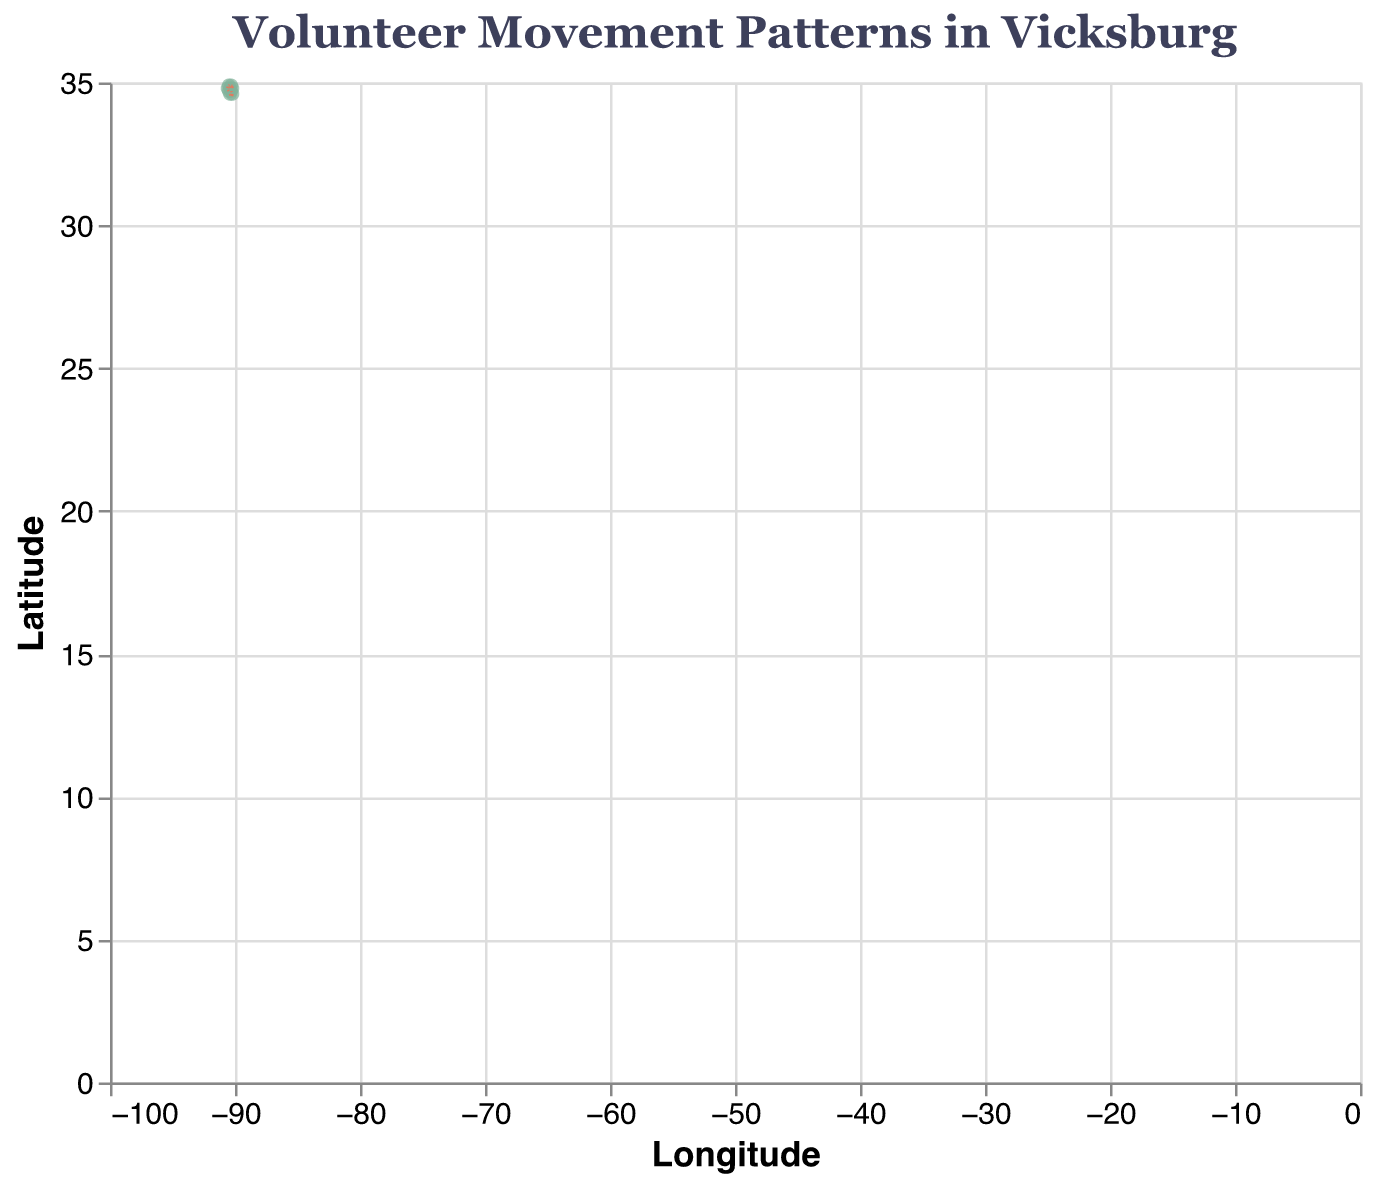What is the title of the plot? The title of the plot is displayed at the top and is usually the most noticeable textual element.
Answer: Volunteer Movement Patterns in Vicksburg How many volunteer locations are displayed in the plot? By counting the distinct data points (or locations) represented in the plot, you can determine the number.
Answer: 9 What color is used to represent the points indicating volunteer locations? The points representing volunteer locations are typically marked with a consistent color for uniformity and to distinguish them easily from other elements.
Answer: #81B29A What is the direction of volunteer movement at the Vicksburg National Military Park? The direction is given by the vector, where `U` represents the horizontal change, and `V` the vertical change. For Vicksburg National Military Park: (0.1, -0.2).
Answer: Right and down Which location exhibits the strongest opposite direction of movement compared to Vicksburg Warren School District? To find the opposite direction, we identify vectors where `U` and `V` components are inverse to those of the Vicksburg Warren School District (-0.2, 0.3).
Answer: Salvation Army of Vicksburg (U=-0.2, V=-0.4) What is the general movement pattern at Vicksburg National Cemetery? Look at the vector associated with the National Cemetery's coordinates. U and V components give the movement pattern: (0.1, 0.3).
Answer: Minor right and significant up Which locations have volunteer movements in the vertical upward direction? Search for vectors with positive V components indicating upward movements in the plot.
Answer: Vicksburg Warren School District, Good Shepherd Community Center, Vicksburg Convention Center, Vicksburg National Cemetery What is the average horizontal movement (U) across all locations? Add up all the `U` values and divide by the number of locations: (-0.2 + 0.1 + 0.3 - 0.1 + 0.2 - 0.3 + 0.4 + 0.1 - 0.2) / 9.
Answer: 0.022 Between the Vicksburg Convention Center and Warren County-Vicksburg Public Library, which had the greater vertical movement? Compare the absolute values of their `V` components (-0.3, 0.2) to see which is larger in magnitude.
Answer: Vicksburg Convention Center Which point shows the longest movement distance? For each location, calculate the vector's magnitude using the formula sqrt(U^2 + V^2), and find the location with the largest value.
Answer: Salvation Army of Vicksburg (Magnitude = sqrt((-0.2)^2 + (-0.4)^2) ≈ 0.45) 